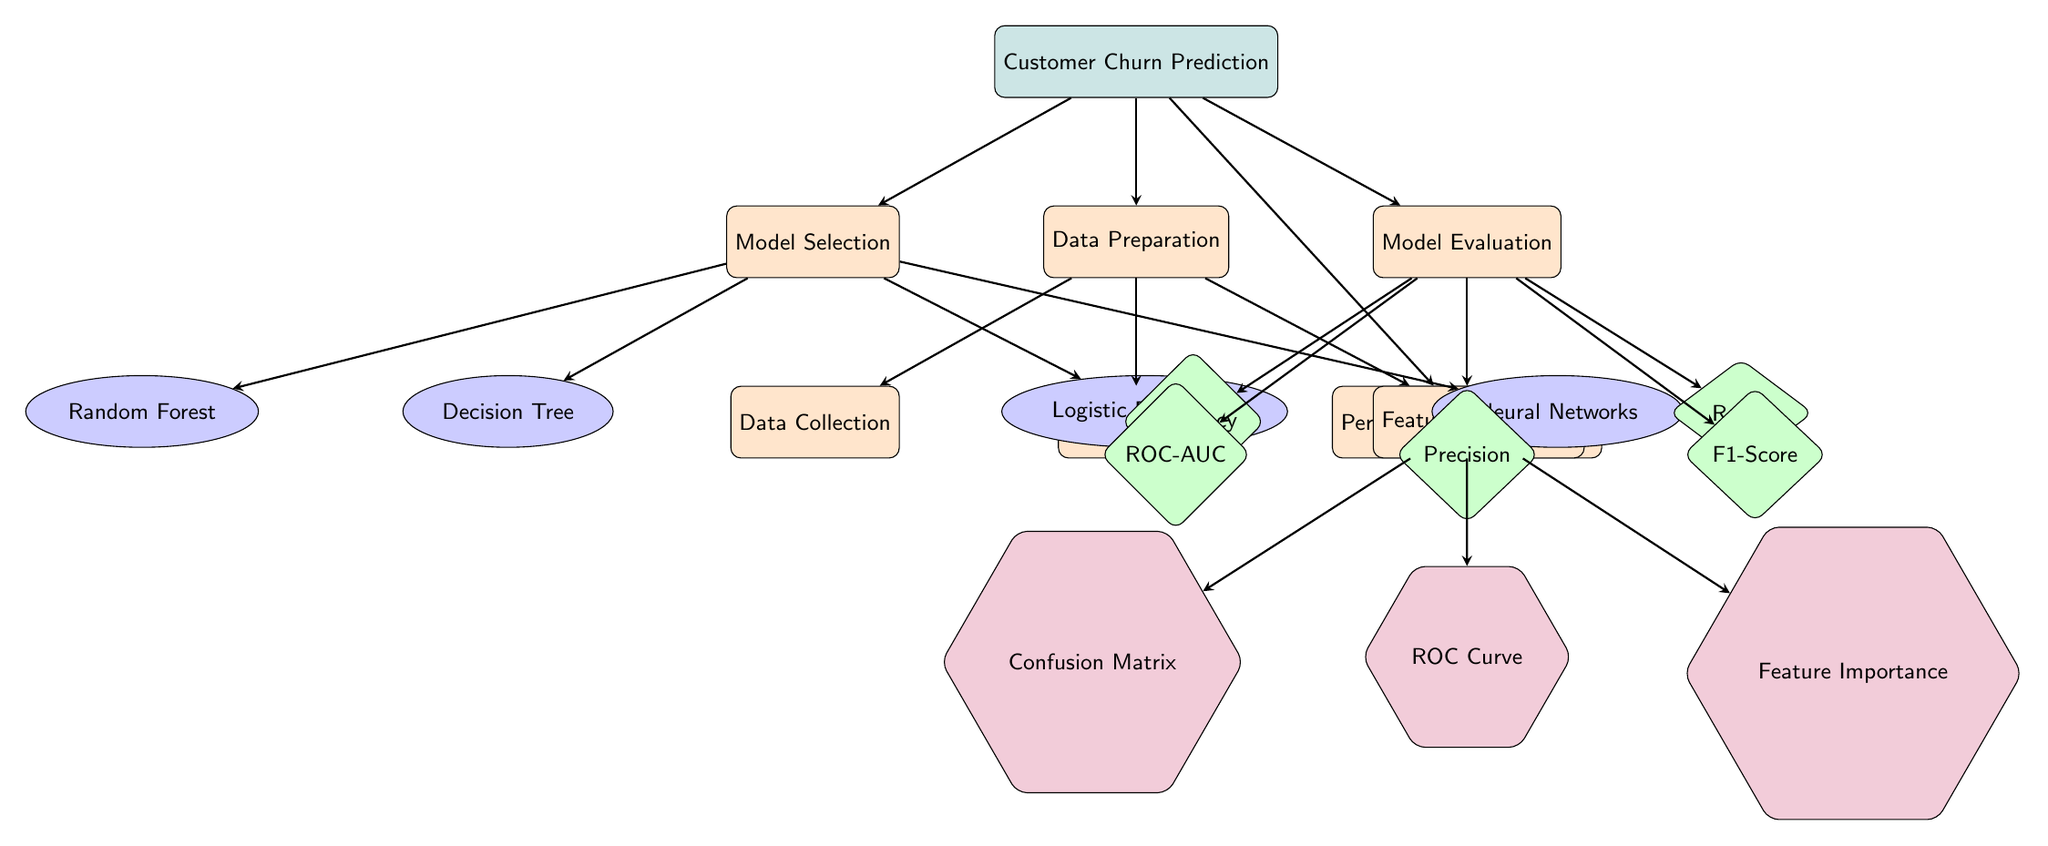what is the main focus of the diagram? The main focus is indicated by the top node which states "Customer Churn Prediction." This node is the starting point and central theme of the diagram.
Answer: Customer Churn Prediction how many main processes are there below the main node? There are three processes directly connected below the main node of "Customer Churn Prediction": Data Preparation, Model Selection, and Model Evaluation, along with Performance Visualization. Counting these, we have four.
Answer: four which predictive algorithm is on the far left? The far left node within the Model Selection section is "Random Forest." This is identified by its position and labeled accordingly in the diagram.
Answer: Random Forest which evaluation metric is positioned to the right of Precision? The metric placed to the right of Precision is "F1-Score." This relation can be observed by tracking the node positions under the Evaluation Metrics section.
Answer: F1-Score name the type of visualization found at the bottom left of the Performance Visualization process. The visualization located at the bottom left node under Performance Visualization is "Confusion Matrix." This can be confirmed by following the connections from the Performance Visualization node down to the sub-nodes.
Answer: Confusion Matrix what is the relationship between Data Preparation and the algorithms? Data Preparation provides the necessary processed data for the model selection phase, which leads to the algorithms. This relationship indicates a flow of information from the Data Preparation node to the Model Selection node, where the algorithms are chosen.
Answer: flow of information which two processes are directly connected to Performance Visualization? The Performance Visualization process connects directly to three sub-nodes: Confusion Matrix, ROC Curve, and Feature Importance. The first two nodes on the left specifically are Confusion Matrix and ROC Curve.
Answer: Confusion Matrix and ROC Curve what are the types of algorithms used in this diagram? The algorithms listed in the diagram include Decision Tree, Random Forest, Logistic Regression, and Neural Networks. Each is represented as a node within the Model Selection section.
Answer: Decision Tree, Random Forest, Logistic Regression, Neural Networks describe the evaluation metrics represented in this diagram. The evaluation metrics included in the diagram comprise Accuracy, Precision, Recall, F1-Score, and ROC-AUC. These are shown as distinct nodes under the Model Evaluation process.
Answer: Accuracy, Precision, Recall, F1-Score, ROC-AUC 